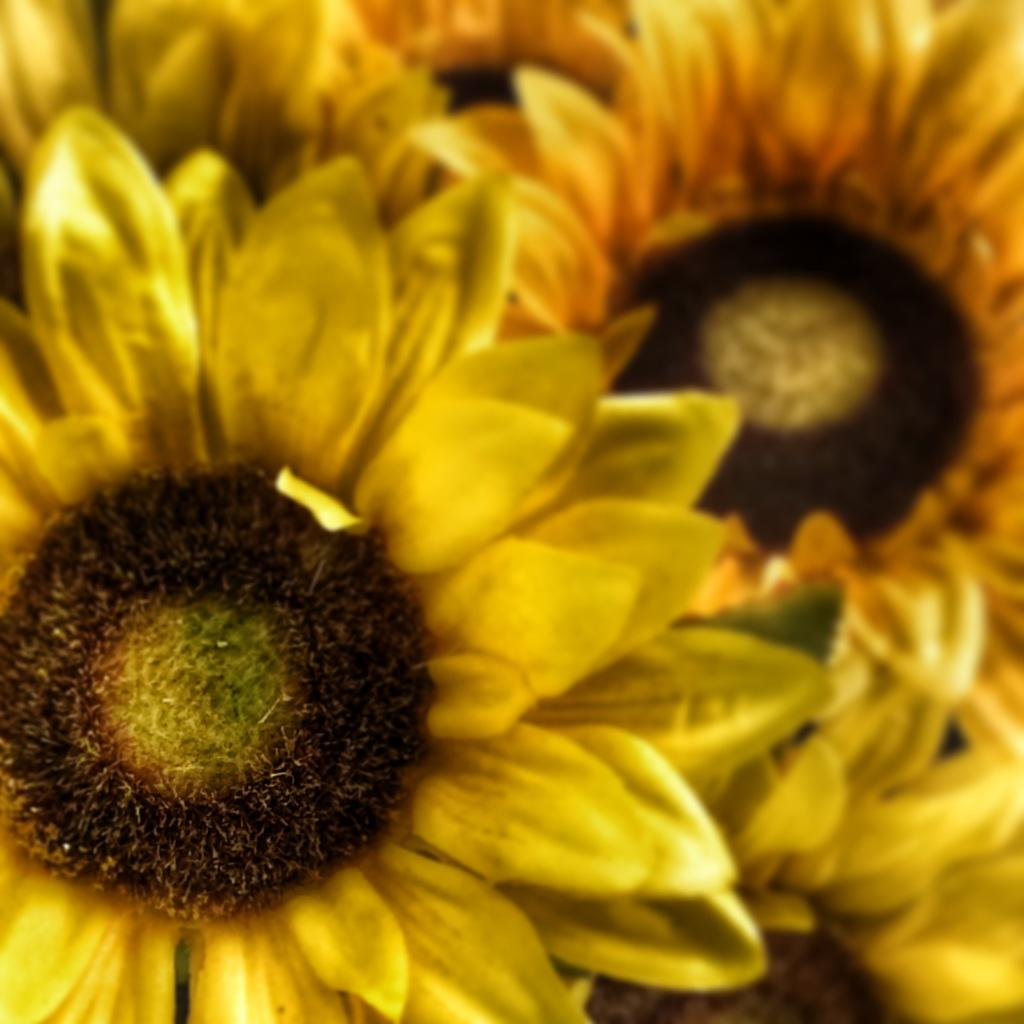What type of flowers are in the image? There are sunflowers in the image. Can you describe the background of the image? The background of the image is blurred. What type of bulb is used to light up the committee meeting in the image? There is no committee meeting or bulb present in the image; it features sunflowers with a blurred background. 